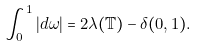<formula> <loc_0><loc_0><loc_500><loc_500>\int _ { 0 } ^ { 1 } | d \omega | = 2 \lambda ( \mathbb { T } ) - \delta ( 0 , 1 ) .</formula> 